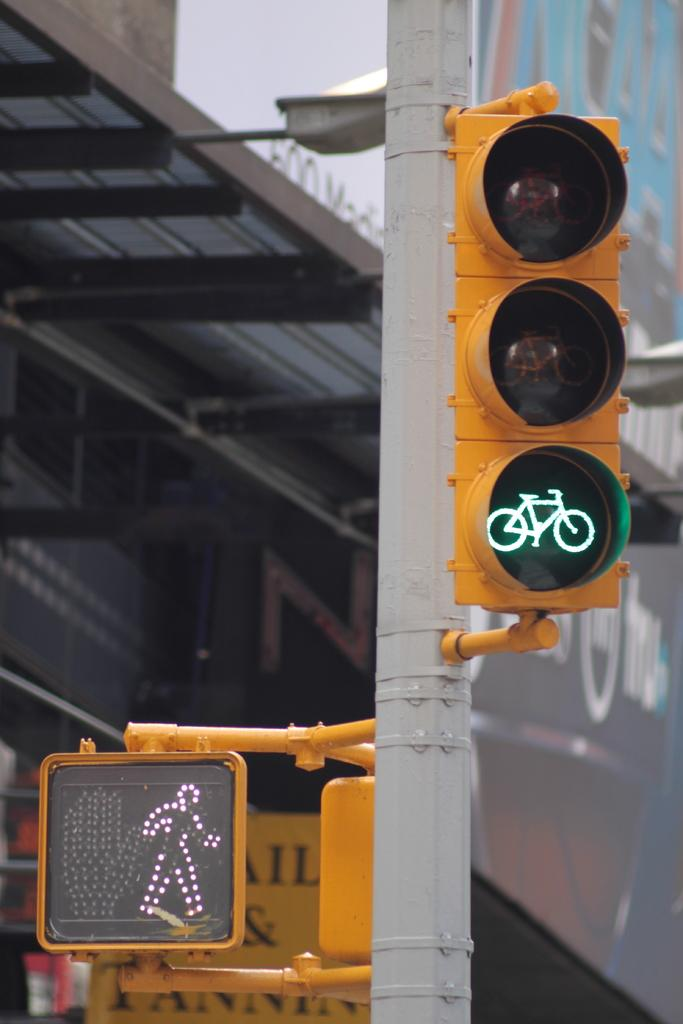<image>
Describe the image concisely. The letters IL and visible behind a walk/don't walk sign. 